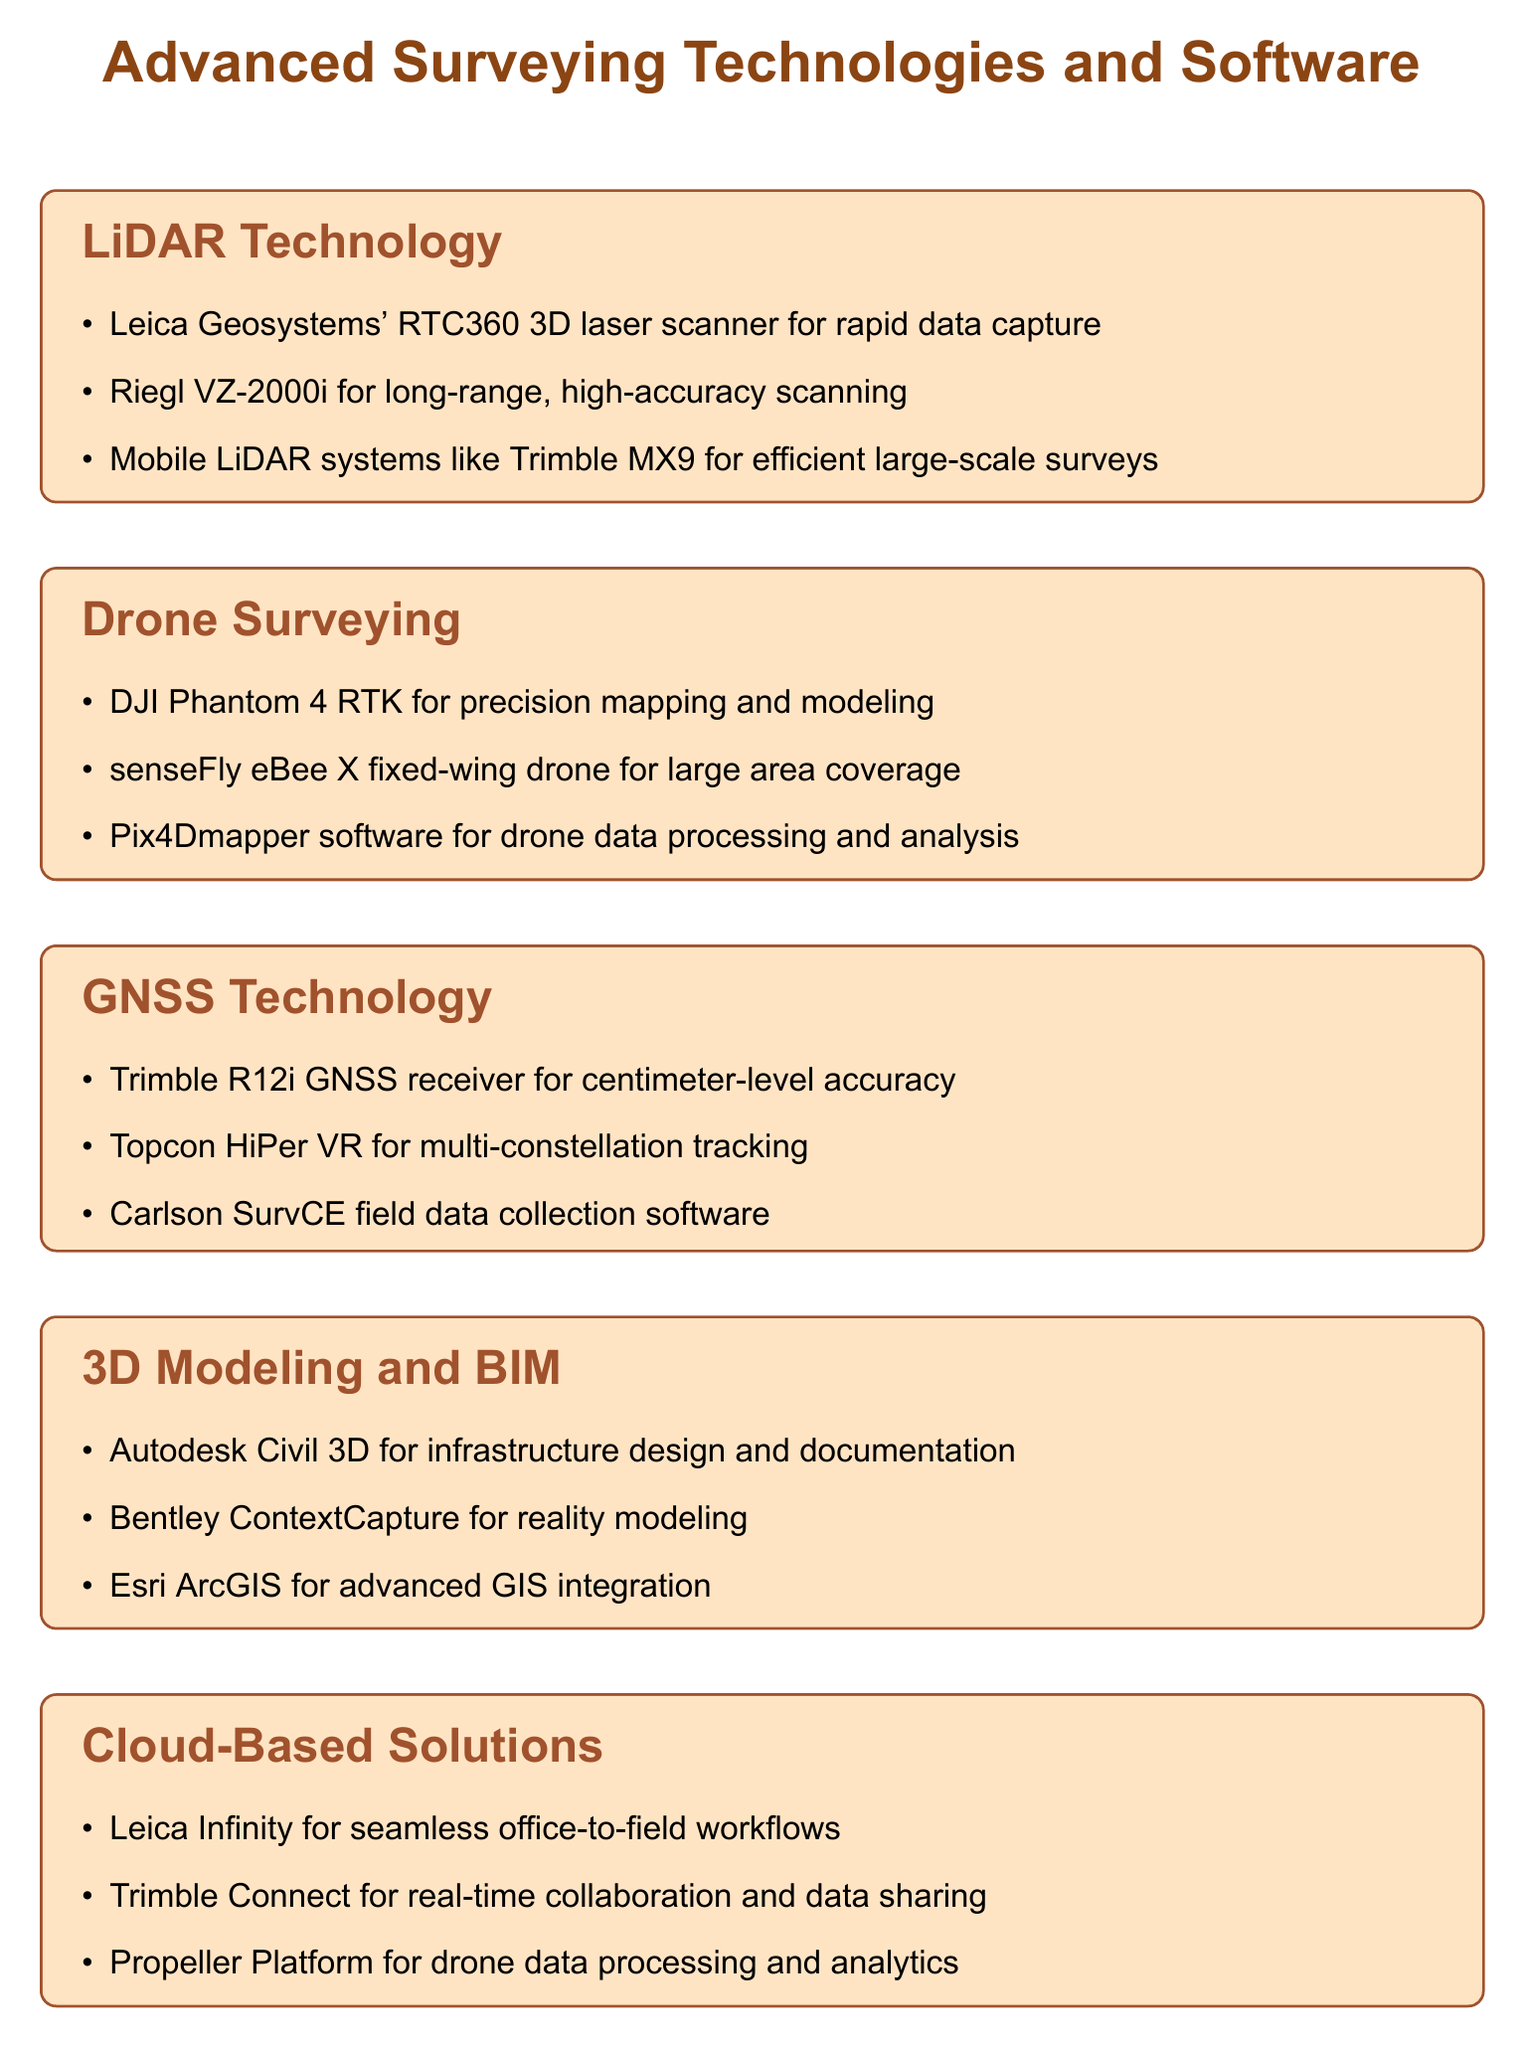What technology is used for rapid data capture? The document mentions the Leica Geosystems' RTC360 3D laser scanner for rapid data capture.
Answer: Leica Geosystems' RTC360 3D laser scanner Which drone is used for precision mapping and modeling? The DJI Phantom 4 RTK is noted in the document for precision mapping and modeling.
Answer: DJI Phantom 4 RTK What is one software used for drone data processing? The document lists Pix4Dmapper software for drone data processing and analysis.
Answer: Pix4Dmapper What device provides centimeter-level accuracy in GNSS technology? The Trimble R12i GNSS receiver is highlighted for providing centimeter-level accuracy.
Answer: Trimble R12i Which software is used for infrastructure design and documentation? Autodesk Civil 3D is specified in the document for infrastructure design and documentation.
Answer: Autodesk Civil 3D Name one benefit of the technologies mentioned in the conclusion. The conclusion states that these technologies enable leading companies to increase efficiency.
Answer: Efficiency How many GNSS technologies are listed in the document? Three technologies are listed under the GNSS Technology section.
Answer: Three What is one cloud-based solution for real-time collaboration? Trimble Connect is mentioned for real-time collaboration and data sharing.
Answer: Trimble Connect 